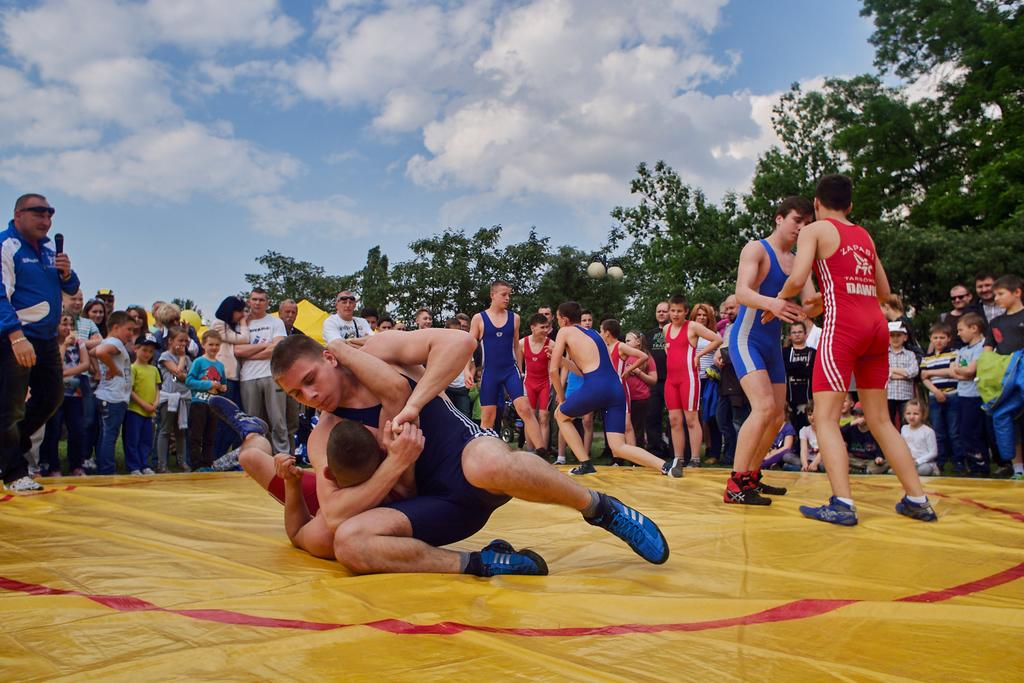What activity are the persons in the image engaged in? The persons in the image are doing wrestling. Can you describe the environment in the image? There is a crowd in the image, and the sky is visible at the top. Where are the persons in the image located? There are persons in the middle of the image. How many ants can be seen carrying linen in the image? There are no ants or linen present in the image. What is the way the wrestlers are using to communicate during the match? The image does not show any specific way of communication between the wrestlers. 